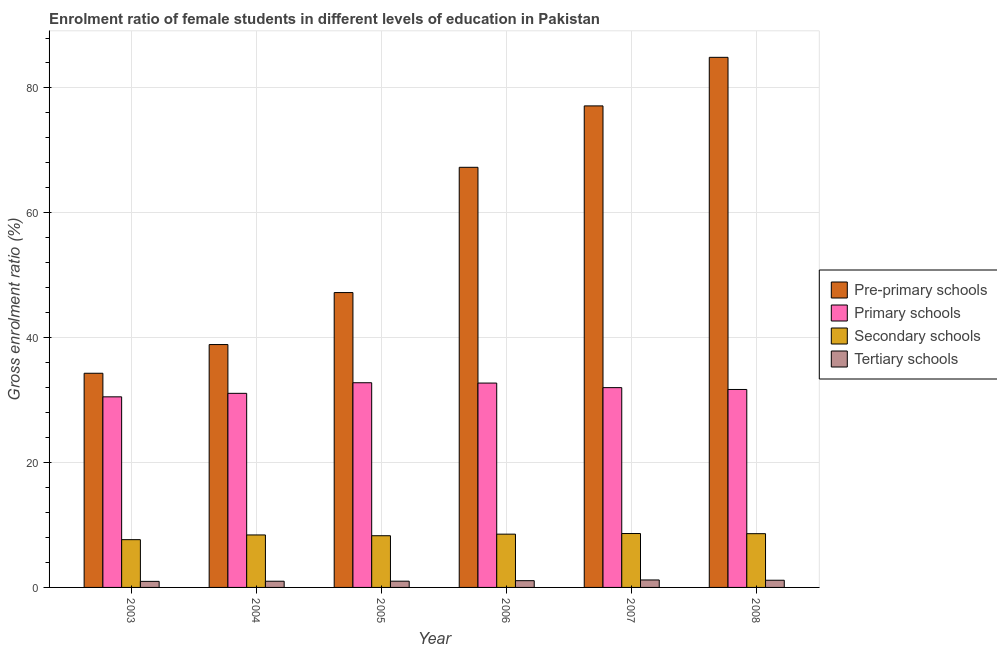How many different coloured bars are there?
Provide a succinct answer. 4. Are the number of bars per tick equal to the number of legend labels?
Give a very brief answer. Yes. How many bars are there on the 5th tick from the left?
Give a very brief answer. 4. How many bars are there on the 1st tick from the right?
Your response must be concise. 4. What is the label of the 4th group of bars from the left?
Provide a succinct answer. 2006. What is the gross enrolment ratio(male) in primary schools in 2005?
Provide a succinct answer. 32.79. Across all years, what is the maximum gross enrolment ratio(male) in tertiary schools?
Your answer should be compact. 1.2. Across all years, what is the minimum gross enrolment ratio(male) in tertiary schools?
Give a very brief answer. 0.97. In which year was the gross enrolment ratio(male) in primary schools maximum?
Your answer should be very brief. 2005. In which year was the gross enrolment ratio(male) in tertiary schools minimum?
Provide a succinct answer. 2003. What is the total gross enrolment ratio(male) in secondary schools in the graph?
Your answer should be very brief. 50.11. What is the difference between the gross enrolment ratio(male) in pre-primary schools in 2004 and that in 2008?
Offer a terse response. -46. What is the difference between the gross enrolment ratio(male) in pre-primary schools in 2004 and the gross enrolment ratio(male) in primary schools in 2006?
Your answer should be very brief. -28.39. What is the average gross enrolment ratio(male) in tertiary schools per year?
Your answer should be compact. 1.07. What is the ratio of the gross enrolment ratio(male) in pre-primary schools in 2004 to that in 2005?
Ensure brevity in your answer.  0.82. What is the difference between the highest and the second highest gross enrolment ratio(male) in primary schools?
Your answer should be compact. 0.05. What is the difference between the highest and the lowest gross enrolment ratio(male) in secondary schools?
Give a very brief answer. 0.98. Is the sum of the gross enrolment ratio(male) in pre-primary schools in 2005 and 2007 greater than the maximum gross enrolment ratio(male) in secondary schools across all years?
Your response must be concise. Yes. Is it the case that in every year, the sum of the gross enrolment ratio(male) in primary schools and gross enrolment ratio(male) in secondary schools is greater than the sum of gross enrolment ratio(male) in tertiary schools and gross enrolment ratio(male) in pre-primary schools?
Provide a short and direct response. Yes. What does the 4th bar from the left in 2005 represents?
Keep it short and to the point. Tertiary schools. What does the 4th bar from the right in 2008 represents?
Offer a very short reply. Pre-primary schools. Is it the case that in every year, the sum of the gross enrolment ratio(male) in pre-primary schools and gross enrolment ratio(male) in primary schools is greater than the gross enrolment ratio(male) in secondary schools?
Offer a very short reply. Yes. How many years are there in the graph?
Offer a terse response. 6. Does the graph contain grids?
Your answer should be very brief. Yes. Where does the legend appear in the graph?
Ensure brevity in your answer.  Center right. How are the legend labels stacked?
Your answer should be very brief. Vertical. What is the title of the graph?
Provide a succinct answer. Enrolment ratio of female students in different levels of education in Pakistan. What is the Gross enrolment ratio (%) of Pre-primary schools in 2003?
Your answer should be compact. 34.3. What is the Gross enrolment ratio (%) of Primary schools in 2003?
Your answer should be very brief. 30.53. What is the Gross enrolment ratio (%) of Secondary schools in 2003?
Make the answer very short. 7.65. What is the Gross enrolment ratio (%) in Tertiary schools in 2003?
Ensure brevity in your answer.  0.97. What is the Gross enrolment ratio (%) in Pre-primary schools in 2004?
Provide a short and direct response. 38.9. What is the Gross enrolment ratio (%) in Primary schools in 2004?
Give a very brief answer. 31.09. What is the Gross enrolment ratio (%) of Secondary schools in 2004?
Give a very brief answer. 8.41. What is the Gross enrolment ratio (%) of Tertiary schools in 2004?
Your answer should be compact. 0.99. What is the Gross enrolment ratio (%) of Pre-primary schools in 2005?
Give a very brief answer. 47.23. What is the Gross enrolment ratio (%) in Primary schools in 2005?
Offer a very short reply. 32.79. What is the Gross enrolment ratio (%) of Secondary schools in 2005?
Your answer should be very brief. 8.28. What is the Gross enrolment ratio (%) in Tertiary schools in 2005?
Your answer should be compact. 1. What is the Gross enrolment ratio (%) in Pre-primary schools in 2006?
Your response must be concise. 67.29. What is the Gross enrolment ratio (%) in Primary schools in 2006?
Offer a terse response. 32.73. What is the Gross enrolment ratio (%) in Secondary schools in 2006?
Your answer should be compact. 8.53. What is the Gross enrolment ratio (%) in Tertiary schools in 2006?
Offer a terse response. 1.08. What is the Gross enrolment ratio (%) of Pre-primary schools in 2007?
Offer a very short reply. 77.13. What is the Gross enrolment ratio (%) of Primary schools in 2007?
Your response must be concise. 32. What is the Gross enrolment ratio (%) in Secondary schools in 2007?
Provide a succinct answer. 8.63. What is the Gross enrolment ratio (%) in Tertiary schools in 2007?
Your answer should be very brief. 1.2. What is the Gross enrolment ratio (%) of Pre-primary schools in 2008?
Provide a succinct answer. 84.91. What is the Gross enrolment ratio (%) of Primary schools in 2008?
Provide a short and direct response. 31.7. What is the Gross enrolment ratio (%) of Secondary schools in 2008?
Your answer should be very brief. 8.61. What is the Gross enrolment ratio (%) of Tertiary schools in 2008?
Ensure brevity in your answer.  1.15. Across all years, what is the maximum Gross enrolment ratio (%) of Pre-primary schools?
Keep it short and to the point. 84.91. Across all years, what is the maximum Gross enrolment ratio (%) of Primary schools?
Keep it short and to the point. 32.79. Across all years, what is the maximum Gross enrolment ratio (%) in Secondary schools?
Ensure brevity in your answer.  8.63. Across all years, what is the maximum Gross enrolment ratio (%) in Tertiary schools?
Provide a succinct answer. 1.2. Across all years, what is the minimum Gross enrolment ratio (%) in Pre-primary schools?
Give a very brief answer. 34.3. Across all years, what is the minimum Gross enrolment ratio (%) of Primary schools?
Keep it short and to the point. 30.53. Across all years, what is the minimum Gross enrolment ratio (%) in Secondary schools?
Offer a very short reply. 7.65. Across all years, what is the minimum Gross enrolment ratio (%) in Tertiary schools?
Provide a succinct answer. 0.97. What is the total Gross enrolment ratio (%) of Pre-primary schools in the graph?
Offer a terse response. 349.76. What is the total Gross enrolment ratio (%) in Primary schools in the graph?
Provide a short and direct response. 190.84. What is the total Gross enrolment ratio (%) of Secondary schools in the graph?
Ensure brevity in your answer.  50.11. What is the total Gross enrolment ratio (%) in Tertiary schools in the graph?
Provide a succinct answer. 6.39. What is the difference between the Gross enrolment ratio (%) of Pre-primary schools in 2003 and that in 2004?
Make the answer very short. -4.6. What is the difference between the Gross enrolment ratio (%) in Primary schools in 2003 and that in 2004?
Your answer should be very brief. -0.56. What is the difference between the Gross enrolment ratio (%) in Secondary schools in 2003 and that in 2004?
Provide a succinct answer. -0.76. What is the difference between the Gross enrolment ratio (%) in Tertiary schools in 2003 and that in 2004?
Offer a very short reply. -0.02. What is the difference between the Gross enrolment ratio (%) in Pre-primary schools in 2003 and that in 2005?
Give a very brief answer. -12.92. What is the difference between the Gross enrolment ratio (%) of Primary schools in 2003 and that in 2005?
Ensure brevity in your answer.  -2.26. What is the difference between the Gross enrolment ratio (%) in Secondary schools in 2003 and that in 2005?
Give a very brief answer. -0.63. What is the difference between the Gross enrolment ratio (%) in Tertiary schools in 2003 and that in 2005?
Your answer should be very brief. -0.03. What is the difference between the Gross enrolment ratio (%) in Pre-primary schools in 2003 and that in 2006?
Provide a succinct answer. -32.99. What is the difference between the Gross enrolment ratio (%) in Primary schools in 2003 and that in 2006?
Give a very brief answer. -2.2. What is the difference between the Gross enrolment ratio (%) in Secondary schools in 2003 and that in 2006?
Provide a succinct answer. -0.88. What is the difference between the Gross enrolment ratio (%) in Tertiary schools in 2003 and that in 2006?
Keep it short and to the point. -0.11. What is the difference between the Gross enrolment ratio (%) in Pre-primary schools in 2003 and that in 2007?
Offer a very short reply. -42.82. What is the difference between the Gross enrolment ratio (%) of Primary schools in 2003 and that in 2007?
Provide a succinct answer. -1.48. What is the difference between the Gross enrolment ratio (%) of Secondary schools in 2003 and that in 2007?
Your answer should be very brief. -0.98. What is the difference between the Gross enrolment ratio (%) in Tertiary schools in 2003 and that in 2007?
Your answer should be very brief. -0.23. What is the difference between the Gross enrolment ratio (%) in Pre-primary schools in 2003 and that in 2008?
Offer a terse response. -50.6. What is the difference between the Gross enrolment ratio (%) in Primary schools in 2003 and that in 2008?
Keep it short and to the point. -1.18. What is the difference between the Gross enrolment ratio (%) of Secondary schools in 2003 and that in 2008?
Offer a terse response. -0.96. What is the difference between the Gross enrolment ratio (%) in Tertiary schools in 2003 and that in 2008?
Give a very brief answer. -0.18. What is the difference between the Gross enrolment ratio (%) of Pre-primary schools in 2004 and that in 2005?
Your answer should be compact. -8.32. What is the difference between the Gross enrolment ratio (%) of Primary schools in 2004 and that in 2005?
Make the answer very short. -1.7. What is the difference between the Gross enrolment ratio (%) of Secondary schools in 2004 and that in 2005?
Ensure brevity in your answer.  0.13. What is the difference between the Gross enrolment ratio (%) of Tertiary schools in 2004 and that in 2005?
Offer a very short reply. -0.01. What is the difference between the Gross enrolment ratio (%) of Pre-primary schools in 2004 and that in 2006?
Ensure brevity in your answer.  -28.39. What is the difference between the Gross enrolment ratio (%) of Primary schools in 2004 and that in 2006?
Give a very brief answer. -1.64. What is the difference between the Gross enrolment ratio (%) in Secondary schools in 2004 and that in 2006?
Keep it short and to the point. -0.13. What is the difference between the Gross enrolment ratio (%) in Tertiary schools in 2004 and that in 2006?
Ensure brevity in your answer.  -0.09. What is the difference between the Gross enrolment ratio (%) of Pre-primary schools in 2004 and that in 2007?
Offer a very short reply. -38.22. What is the difference between the Gross enrolment ratio (%) in Primary schools in 2004 and that in 2007?
Make the answer very short. -0.92. What is the difference between the Gross enrolment ratio (%) of Secondary schools in 2004 and that in 2007?
Your answer should be compact. -0.23. What is the difference between the Gross enrolment ratio (%) of Tertiary schools in 2004 and that in 2007?
Give a very brief answer. -0.2. What is the difference between the Gross enrolment ratio (%) of Pre-primary schools in 2004 and that in 2008?
Your answer should be compact. -46. What is the difference between the Gross enrolment ratio (%) of Primary schools in 2004 and that in 2008?
Your answer should be very brief. -0.62. What is the difference between the Gross enrolment ratio (%) of Secondary schools in 2004 and that in 2008?
Make the answer very short. -0.2. What is the difference between the Gross enrolment ratio (%) in Tertiary schools in 2004 and that in 2008?
Offer a terse response. -0.16. What is the difference between the Gross enrolment ratio (%) in Pre-primary schools in 2005 and that in 2006?
Make the answer very short. -20.07. What is the difference between the Gross enrolment ratio (%) in Primary schools in 2005 and that in 2006?
Keep it short and to the point. 0.05. What is the difference between the Gross enrolment ratio (%) in Secondary schools in 2005 and that in 2006?
Offer a terse response. -0.25. What is the difference between the Gross enrolment ratio (%) of Tertiary schools in 2005 and that in 2006?
Your response must be concise. -0.08. What is the difference between the Gross enrolment ratio (%) of Pre-primary schools in 2005 and that in 2007?
Make the answer very short. -29.9. What is the difference between the Gross enrolment ratio (%) of Primary schools in 2005 and that in 2007?
Offer a very short reply. 0.78. What is the difference between the Gross enrolment ratio (%) in Secondary schools in 2005 and that in 2007?
Provide a short and direct response. -0.35. What is the difference between the Gross enrolment ratio (%) in Tertiary schools in 2005 and that in 2007?
Keep it short and to the point. -0.19. What is the difference between the Gross enrolment ratio (%) in Pre-primary schools in 2005 and that in 2008?
Your answer should be very brief. -37.68. What is the difference between the Gross enrolment ratio (%) of Primary schools in 2005 and that in 2008?
Keep it short and to the point. 1.08. What is the difference between the Gross enrolment ratio (%) in Secondary schools in 2005 and that in 2008?
Your answer should be compact. -0.33. What is the difference between the Gross enrolment ratio (%) of Tertiary schools in 2005 and that in 2008?
Your answer should be compact. -0.15. What is the difference between the Gross enrolment ratio (%) of Pre-primary schools in 2006 and that in 2007?
Your answer should be very brief. -9.83. What is the difference between the Gross enrolment ratio (%) in Primary schools in 2006 and that in 2007?
Keep it short and to the point. 0.73. What is the difference between the Gross enrolment ratio (%) of Secondary schools in 2006 and that in 2007?
Keep it short and to the point. -0.1. What is the difference between the Gross enrolment ratio (%) of Tertiary schools in 2006 and that in 2007?
Offer a very short reply. -0.12. What is the difference between the Gross enrolment ratio (%) in Pre-primary schools in 2006 and that in 2008?
Your response must be concise. -17.61. What is the difference between the Gross enrolment ratio (%) in Primary schools in 2006 and that in 2008?
Offer a very short reply. 1.03. What is the difference between the Gross enrolment ratio (%) in Secondary schools in 2006 and that in 2008?
Offer a very short reply. -0.08. What is the difference between the Gross enrolment ratio (%) in Tertiary schools in 2006 and that in 2008?
Offer a terse response. -0.07. What is the difference between the Gross enrolment ratio (%) of Pre-primary schools in 2007 and that in 2008?
Give a very brief answer. -7.78. What is the difference between the Gross enrolment ratio (%) in Primary schools in 2007 and that in 2008?
Keep it short and to the point. 0.3. What is the difference between the Gross enrolment ratio (%) in Secondary schools in 2007 and that in 2008?
Your response must be concise. 0.03. What is the difference between the Gross enrolment ratio (%) in Tertiary schools in 2007 and that in 2008?
Your answer should be compact. 0.04. What is the difference between the Gross enrolment ratio (%) in Pre-primary schools in 2003 and the Gross enrolment ratio (%) in Primary schools in 2004?
Ensure brevity in your answer.  3.22. What is the difference between the Gross enrolment ratio (%) of Pre-primary schools in 2003 and the Gross enrolment ratio (%) of Secondary schools in 2004?
Provide a succinct answer. 25.9. What is the difference between the Gross enrolment ratio (%) in Pre-primary schools in 2003 and the Gross enrolment ratio (%) in Tertiary schools in 2004?
Ensure brevity in your answer.  33.31. What is the difference between the Gross enrolment ratio (%) of Primary schools in 2003 and the Gross enrolment ratio (%) of Secondary schools in 2004?
Your answer should be very brief. 22.12. What is the difference between the Gross enrolment ratio (%) of Primary schools in 2003 and the Gross enrolment ratio (%) of Tertiary schools in 2004?
Ensure brevity in your answer.  29.53. What is the difference between the Gross enrolment ratio (%) in Secondary schools in 2003 and the Gross enrolment ratio (%) in Tertiary schools in 2004?
Provide a succinct answer. 6.66. What is the difference between the Gross enrolment ratio (%) in Pre-primary schools in 2003 and the Gross enrolment ratio (%) in Primary schools in 2005?
Provide a short and direct response. 1.52. What is the difference between the Gross enrolment ratio (%) of Pre-primary schools in 2003 and the Gross enrolment ratio (%) of Secondary schools in 2005?
Make the answer very short. 26.02. What is the difference between the Gross enrolment ratio (%) of Pre-primary schools in 2003 and the Gross enrolment ratio (%) of Tertiary schools in 2005?
Provide a succinct answer. 33.3. What is the difference between the Gross enrolment ratio (%) of Primary schools in 2003 and the Gross enrolment ratio (%) of Secondary schools in 2005?
Your answer should be very brief. 22.25. What is the difference between the Gross enrolment ratio (%) of Primary schools in 2003 and the Gross enrolment ratio (%) of Tertiary schools in 2005?
Your answer should be compact. 29.53. What is the difference between the Gross enrolment ratio (%) of Secondary schools in 2003 and the Gross enrolment ratio (%) of Tertiary schools in 2005?
Ensure brevity in your answer.  6.65. What is the difference between the Gross enrolment ratio (%) of Pre-primary schools in 2003 and the Gross enrolment ratio (%) of Primary schools in 2006?
Your answer should be compact. 1.57. What is the difference between the Gross enrolment ratio (%) of Pre-primary schools in 2003 and the Gross enrolment ratio (%) of Secondary schools in 2006?
Ensure brevity in your answer.  25.77. What is the difference between the Gross enrolment ratio (%) of Pre-primary schools in 2003 and the Gross enrolment ratio (%) of Tertiary schools in 2006?
Ensure brevity in your answer.  33.22. What is the difference between the Gross enrolment ratio (%) of Primary schools in 2003 and the Gross enrolment ratio (%) of Secondary schools in 2006?
Offer a terse response. 21.99. What is the difference between the Gross enrolment ratio (%) of Primary schools in 2003 and the Gross enrolment ratio (%) of Tertiary schools in 2006?
Offer a very short reply. 29.45. What is the difference between the Gross enrolment ratio (%) in Secondary schools in 2003 and the Gross enrolment ratio (%) in Tertiary schools in 2006?
Keep it short and to the point. 6.57. What is the difference between the Gross enrolment ratio (%) of Pre-primary schools in 2003 and the Gross enrolment ratio (%) of Primary schools in 2007?
Provide a short and direct response. 2.3. What is the difference between the Gross enrolment ratio (%) of Pre-primary schools in 2003 and the Gross enrolment ratio (%) of Secondary schools in 2007?
Keep it short and to the point. 25.67. What is the difference between the Gross enrolment ratio (%) of Pre-primary schools in 2003 and the Gross enrolment ratio (%) of Tertiary schools in 2007?
Keep it short and to the point. 33.11. What is the difference between the Gross enrolment ratio (%) of Primary schools in 2003 and the Gross enrolment ratio (%) of Secondary schools in 2007?
Give a very brief answer. 21.89. What is the difference between the Gross enrolment ratio (%) in Primary schools in 2003 and the Gross enrolment ratio (%) in Tertiary schools in 2007?
Offer a terse response. 29.33. What is the difference between the Gross enrolment ratio (%) of Secondary schools in 2003 and the Gross enrolment ratio (%) of Tertiary schools in 2007?
Ensure brevity in your answer.  6.45. What is the difference between the Gross enrolment ratio (%) of Pre-primary schools in 2003 and the Gross enrolment ratio (%) of Primary schools in 2008?
Give a very brief answer. 2.6. What is the difference between the Gross enrolment ratio (%) in Pre-primary schools in 2003 and the Gross enrolment ratio (%) in Secondary schools in 2008?
Your response must be concise. 25.69. What is the difference between the Gross enrolment ratio (%) in Pre-primary schools in 2003 and the Gross enrolment ratio (%) in Tertiary schools in 2008?
Your answer should be very brief. 33.15. What is the difference between the Gross enrolment ratio (%) in Primary schools in 2003 and the Gross enrolment ratio (%) in Secondary schools in 2008?
Your response must be concise. 21.92. What is the difference between the Gross enrolment ratio (%) in Primary schools in 2003 and the Gross enrolment ratio (%) in Tertiary schools in 2008?
Your answer should be compact. 29.37. What is the difference between the Gross enrolment ratio (%) of Secondary schools in 2003 and the Gross enrolment ratio (%) of Tertiary schools in 2008?
Your answer should be compact. 6.5. What is the difference between the Gross enrolment ratio (%) of Pre-primary schools in 2004 and the Gross enrolment ratio (%) of Primary schools in 2005?
Ensure brevity in your answer.  6.12. What is the difference between the Gross enrolment ratio (%) in Pre-primary schools in 2004 and the Gross enrolment ratio (%) in Secondary schools in 2005?
Your answer should be very brief. 30.62. What is the difference between the Gross enrolment ratio (%) of Pre-primary schools in 2004 and the Gross enrolment ratio (%) of Tertiary schools in 2005?
Keep it short and to the point. 37.9. What is the difference between the Gross enrolment ratio (%) in Primary schools in 2004 and the Gross enrolment ratio (%) in Secondary schools in 2005?
Your answer should be compact. 22.81. What is the difference between the Gross enrolment ratio (%) of Primary schools in 2004 and the Gross enrolment ratio (%) of Tertiary schools in 2005?
Provide a short and direct response. 30.09. What is the difference between the Gross enrolment ratio (%) of Secondary schools in 2004 and the Gross enrolment ratio (%) of Tertiary schools in 2005?
Your response must be concise. 7.41. What is the difference between the Gross enrolment ratio (%) of Pre-primary schools in 2004 and the Gross enrolment ratio (%) of Primary schools in 2006?
Offer a terse response. 6.17. What is the difference between the Gross enrolment ratio (%) in Pre-primary schools in 2004 and the Gross enrolment ratio (%) in Secondary schools in 2006?
Keep it short and to the point. 30.37. What is the difference between the Gross enrolment ratio (%) in Pre-primary schools in 2004 and the Gross enrolment ratio (%) in Tertiary schools in 2006?
Your answer should be compact. 37.82. What is the difference between the Gross enrolment ratio (%) in Primary schools in 2004 and the Gross enrolment ratio (%) in Secondary schools in 2006?
Your answer should be compact. 22.55. What is the difference between the Gross enrolment ratio (%) in Primary schools in 2004 and the Gross enrolment ratio (%) in Tertiary schools in 2006?
Ensure brevity in your answer.  30.01. What is the difference between the Gross enrolment ratio (%) of Secondary schools in 2004 and the Gross enrolment ratio (%) of Tertiary schools in 2006?
Provide a short and direct response. 7.33. What is the difference between the Gross enrolment ratio (%) in Pre-primary schools in 2004 and the Gross enrolment ratio (%) in Primary schools in 2007?
Provide a succinct answer. 6.9. What is the difference between the Gross enrolment ratio (%) in Pre-primary schools in 2004 and the Gross enrolment ratio (%) in Secondary schools in 2007?
Your response must be concise. 30.27. What is the difference between the Gross enrolment ratio (%) of Pre-primary schools in 2004 and the Gross enrolment ratio (%) of Tertiary schools in 2007?
Your response must be concise. 37.71. What is the difference between the Gross enrolment ratio (%) of Primary schools in 2004 and the Gross enrolment ratio (%) of Secondary schools in 2007?
Keep it short and to the point. 22.45. What is the difference between the Gross enrolment ratio (%) in Primary schools in 2004 and the Gross enrolment ratio (%) in Tertiary schools in 2007?
Your response must be concise. 29.89. What is the difference between the Gross enrolment ratio (%) of Secondary schools in 2004 and the Gross enrolment ratio (%) of Tertiary schools in 2007?
Your answer should be compact. 7.21. What is the difference between the Gross enrolment ratio (%) in Pre-primary schools in 2004 and the Gross enrolment ratio (%) in Primary schools in 2008?
Offer a terse response. 7.2. What is the difference between the Gross enrolment ratio (%) in Pre-primary schools in 2004 and the Gross enrolment ratio (%) in Secondary schools in 2008?
Provide a succinct answer. 30.29. What is the difference between the Gross enrolment ratio (%) of Pre-primary schools in 2004 and the Gross enrolment ratio (%) of Tertiary schools in 2008?
Provide a short and direct response. 37.75. What is the difference between the Gross enrolment ratio (%) in Primary schools in 2004 and the Gross enrolment ratio (%) in Secondary schools in 2008?
Keep it short and to the point. 22.48. What is the difference between the Gross enrolment ratio (%) of Primary schools in 2004 and the Gross enrolment ratio (%) of Tertiary schools in 2008?
Provide a succinct answer. 29.94. What is the difference between the Gross enrolment ratio (%) in Secondary schools in 2004 and the Gross enrolment ratio (%) in Tertiary schools in 2008?
Ensure brevity in your answer.  7.25. What is the difference between the Gross enrolment ratio (%) in Pre-primary schools in 2005 and the Gross enrolment ratio (%) in Primary schools in 2006?
Your answer should be very brief. 14.5. What is the difference between the Gross enrolment ratio (%) of Pre-primary schools in 2005 and the Gross enrolment ratio (%) of Secondary schools in 2006?
Your answer should be compact. 38.69. What is the difference between the Gross enrolment ratio (%) in Pre-primary schools in 2005 and the Gross enrolment ratio (%) in Tertiary schools in 2006?
Your answer should be very brief. 46.15. What is the difference between the Gross enrolment ratio (%) of Primary schools in 2005 and the Gross enrolment ratio (%) of Secondary schools in 2006?
Make the answer very short. 24.25. What is the difference between the Gross enrolment ratio (%) in Primary schools in 2005 and the Gross enrolment ratio (%) in Tertiary schools in 2006?
Your answer should be very brief. 31.71. What is the difference between the Gross enrolment ratio (%) in Secondary schools in 2005 and the Gross enrolment ratio (%) in Tertiary schools in 2006?
Give a very brief answer. 7.2. What is the difference between the Gross enrolment ratio (%) of Pre-primary schools in 2005 and the Gross enrolment ratio (%) of Primary schools in 2007?
Provide a succinct answer. 15.22. What is the difference between the Gross enrolment ratio (%) in Pre-primary schools in 2005 and the Gross enrolment ratio (%) in Secondary schools in 2007?
Make the answer very short. 38.59. What is the difference between the Gross enrolment ratio (%) in Pre-primary schools in 2005 and the Gross enrolment ratio (%) in Tertiary schools in 2007?
Provide a short and direct response. 46.03. What is the difference between the Gross enrolment ratio (%) in Primary schools in 2005 and the Gross enrolment ratio (%) in Secondary schools in 2007?
Offer a terse response. 24.15. What is the difference between the Gross enrolment ratio (%) of Primary schools in 2005 and the Gross enrolment ratio (%) of Tertiary schools in 2007?
Make the answer very short. 31.59. What is the difference between the Gross enrolment ratio (%) in Secondary schools in 2005 and the Gross enrolment ratio (%) in Tertiary schools in 2007?
Make the answer very short. 7.09. What is the difference between the Gross enrolment ratio (%) of Pre-primary schools in 2005 and the Gross enrolment ratio (%) of Primary schools in 2008?
Provide a short and direct response. 15.52. What is the difference between the Gross enrolment ratio (%) in Pre-primary schools in 2005 and the Gross enrolment ratio (%) in Secondary schools in 2008?
Your answer should be compact. 38.62. What is the difference between the Gross enrolment ratio (%) in Pre-primary schools in 2005 and the Gross enrolment ratio (%) in Tertiary schools in 2008?
Provide a short and direct response. 46.07. What is the difference between the Gross enrolment ratio (%) in Primary schools in 2005 and the Gross enrolment ratio (%) in Secondary schools in 2008?
Offer a very short reply. 24.18. What is the difference between the Gross enrolment ratio (%) of Primary schools in 2005 and the Gross enrolment ratio (%) of Tertiary schools in 2008?
Your answer should be compact. 31.63. What is the difference between the Gross enrolment ratio (%) in Secondary schools in 2005 and the Gross enrolment ratio (%) in Tertiary schools in 2008?
Your answer should be compact. 7.13. What is the difference between the Gross enrolment ratio (%) in Pre-primary schools in 2006 and the Gross enrolment ratio (%) in Primary schools in 2007?
Your answer should be very brief. 35.29. What is the difference between the Gross enrolment ratio (%) in Pre-primary schools in 2006 and the Gross enrolment ratio (%) in Secondary schools in 2007?
Make the answer very short. 58.66. What is the difference between the Gross enrolment ratio (%) in Pre-primary schools in 2006 and the Gross enrolment ratio (%) in Tertiary schools in 2007?
Your response must be concise. 66.1. What is the difference between the Gross enrolment ratio (%) of Primary schools in 2006 and the Gross enrolment ratio (%) of Secondary schools in 2007?
Give a very brief answer. 24.1. What is the difference between the Gross enrolment ratio (%) of Primary schools in 2006 and the Gross enrolment ratio (%) of Tertiary schools in 2007?
Offer a very short reply. 31.54. What is the difference between the Gross enrolment ratio (%) in Secondary schools in 2006 and the Gross enrolment ratio (%) in Tertiary schools in 2007?
Offer a terse response. 7.34. What is the difference between the Gross enrolment ratio (%) in Pre-primary schools in 2006 and the Gross enrolment ratio (%) in Primary schools in 2008?
Provide a succinct answer. 35.59. What is the difference between the Gross enrolment ratio (%) of Pre-primary schools in 2006 and the Gross enrolment ratio (%) of Secondary schools in 2008?
Ensure brevity in your answer.  58.68. What is the difference between the Gross enrolment ratio (%) in Pre-primary schools in 2006 and the Gross enrolment ratio (%) in Tertiary schools in 2008?
Give a very brief answer. 66.14. What is the difference between the Gross enrolment ratio (%) of Primary schools in 2006 and the Gross enrolment ratio (%) of Secondary schools in 2008?
Offer a terse response. 24.12. What is the difference between the Gross enrolment ratio (%) in Primary schools in 2006 and the Gross enrolment ratio (%) in Tertiary schools in 2008?
Ensure brevity in your answer.  31.58. What is the difference between the Gross enrolment ratio (%) of Secondary schools in 2006 and the Gross enrolment ratio (%) of Tertiary schools in 2008?
Provide a succinct answer. 7.38. What is the difference between the Gross enrolment ratio (%) of Pre-primary schools in 2007 and the Gross enrolment ratio (%) of Primary schools in 2008?
Provide a short and direct response. 45.42. What is the difference between the Gross enrolment ratio (%) of Pre-primary schools in 2007 and the Gross enrolment ratio (%) of Secondary schools in 2008?
Ensure brevity in your answer.  68.52. What is the difference between the Gross enrolment ratio (%) of Pre-primary schools in 2007 and the Gross enrolment ratio (%) of Tertiary schools in 2008?
Offer a terse response. 75.97. What is the difference between the Gross enrolment ratio (%) in Primary schools in 2007 and the Gross enrolment ratio (%) in Secondary schools in 2008?
Keep it short and to the point. 23.39. What is the difference between the Gross enrolment ratio (%) in Primary schools in 2007 and the Gross enrolment ratio (%) in Tertiary schools in 2008?
Offer a very short reply. 30.85. What is the difference between the Gross enrolment ratio (%) in Secondary schools in 2007 and the Gross enrolment ratio (%) in Tertiary schools in 2008?
Your response must be concise. 7.48. What is the average Gross enrolment ratio (%) of Pre-primary schools per year?
Offer a very short reply. 58.29. What is the average Gross enrolment ratio (%) in Primary schools per year?
Make the answer very short. 31.81. What is the average Gross enrolment ratio (%) of Secondary schools per year?
Make the answer very short. 8.35. What is the average Gross enrolment ratio (%) of Tertiary schools per year?
Your response must be concise. 1.07. In the year 2003, what is the difference between the Gross enrolment ratio (%) of Pre-primary schools and Gross enrolment ratio (%) of Primary schools?
Offer a very short reply. 3.78. In the year 2003, what is the difference between the Gross enrolment ratio (%) in Pre-primary schools and Gross enrolment ratio (%) in Secondary schools?
Your response must be concise. 26.65. In the year 2003, what is the difference between the Gross enrolment ratio (%) in Pre-primary schools and Gross enrolment ratio (%) in Tertiary schools?
Give a very brief answer. 33.33. In the year 2003, what is the difference between the Gross enrolment ratio (%) of Primary schools and Gross enrolment ratio (%) of Secondary schools?
Give a very brief answer. 22.88. In the year 2003, what is the difference between the Gross enrolment ratio (%) of Primary schools and Gross enrolment ratio (%) of Tertiary schools?
Your answer should be compact. 29.56. In the year 2003, what is the difference between the Gross enrolment ratio (%) of Secondary schools and Gross enrolment ratio (%) of Tertiary schools?
Offer a terse response. 6.68. In the year 2004, what is the difference between the Gross enrolment ratio (%) of Pre-primary schools and Gross enrolment ratio (%) of Primary schools?
Provide a short and direct response. 7.81. In the year 2004, what is the difference between the Gross enrolment ratio (%) in Pre-primary schools and Gross enrolment ratio (%) in Secondary schools?
Provide a short and direct response. 30.5. In the year 2004, what is the difference between the Gross enrolment ratio (%) of Pre-primary schools and Gross enrolment ratio (%) of Tertiary schools?
Provide a short and direct response. 37.91. In the year 2004, what is the difference between the Gross enrolment ratio (%) of Primary schools and Gross enrolment ratio (%) of Secondary schools?
Your answer should be compact. 22.68. In the year 2004, what is the difference between the Gross enrolment ratio (%) in Primary schools and Gross enrolment ratio (%) in Tertiary schools?
Your answer should be very brief. 30.09. In the year 2004, what is the difference between the Gross enrolment ratio (%) of Secondary schools and Gross enrolment ratio (%) of Tertiary schools?
Your answer should be compact. 7.41. In the year 2005, what is the difference between the Gross enrolment ratio (%) of Pre-primary schools and Gross enrolment ratio (%) of Primary schools?
Your answer should be very brief. 14.44. In the year 2005, what is the difference between the Gross enrolment ratio (%) in Pre-primary schools and Gross enrolment ratio (%) in Secondary schools?
Your response must be concise. 38.95. In the year 2005, what is the difference between the Gross enrolment ratio (%) in Pre-primary schools and Gross enrolment ratio (%) in Tertiary schools?
Your answer should be compact. 46.23. In the year 2005, what is the difference between the Gross enrolment ratio (%) in Primary schools and Gross enrolment ratio (%) in Secondary schools?
Give a very brief answer. 24.5. In the year 2005, what is the difference between the Gross enrolment ratio (%) in Primary schools and Gross enrolment ratio (%) in Tertiary schools?
Give a very brief answer. 31.78. In the year 2005, what is the difference between the Gross enrolment ratio (%) of Secondary schools and Gross enrolment ratio (%) of Tertiary schools?
Your answer should be very brief. 7.28. In the year 2006, what is the difference between the Gross enrolment ratio (%) of Pre-primary schools and Gross enrolment ratio (%) of Primary schools?
Provide a succinct answer. 34.56. In the year 2006, what is the difference between the Gross enrolment ratio (%) in Pre-primary schools and Gross enrolment ratio (%) in Secondary schools?
Your answer should be compact. 58.76. In the year 2006, what is the difference between the Gross enrolment ratio (%) of Pre-primary schools and Gross enrolment ratio (%) of Tertiary schools?
Give a very brief answer. 66.21. In the year 2006, what is the difference between the Gross enrolment ratio (%) of Primary schools and Gross enrolment ratio (%) of Secondary schools?
Ensure brevity in your answer.  24.2. In the year 2006, what is the difference between the Gross enrolment ratio (%) of Primary schools and Gross enrolment ratio (%) of Tertiary schools?
Provide a succinct answer. 31.65. In the year 2006, what is the difference between the Gross enrolment ratio (%) in Secondary schools and Gross enrolment ratio (%) in Tertiary schools?
Your response must be concise. 7.45. In the year 2007, what is the difference between the Gross enrolment ratio (%) in Pre-primary schools and Gross enrolment ratio (%) in Primary schools?
Make the answer very short. 45.12. In the year 2007, what is the difference between the Gross enrolment ratio (%) of Pre-primary schools and Gross enrolment ratio (%) of Secondary schools?
Make the answer very short. 68.49. In the year 2007, what is the difference between the Gross enrolment ratio (%) of Pre-primary schools and Gross enrolment ratio (%) of Tertiary schools?
Offer a very short reply. 75.93. In the year 2007, what is the difference between the Gross enrolment ratio (%) in Primary schools and Gross enrolment ratio (%) in Secondary schools?
Offer a terse response. 23.37. In the year 2007, what is the difference between the Gross enrolment ratio (%) in Primary schools and Gross enrolment ratio (%) in Tertiary schools?
Offer a very short reply. 30.81. In the year 2007, what is the difference between the Gross enrolment ratio (%) of Secondary schools and Gross enrolment ratio (%) of Tertiary schools?
Provide a succinct answer. 7.44. In the year 2008, what is the difference between the Gross enrolment ratio (%) of Pre-primary schools and Gross enrolment ratio (%) of Primary schools?
Keep it short and to the point. 53.2. In the year 2008, what is the difference between the Gross enrolment ratio (%) in Pre-primary schools and Gross enrolment ratio (%) in Secondary schools?
Your answer should be compact. 76.3. In the year 2008, what is the difference between the Gross enrolment ratio (%) in Pre-primary schools and Gross enrolment ratio (%) in Tertiary schools?
Your answer should be very brief. 83.75. In the year 2008, what is the difference between the Gross enrolment ratio (%) of Primary schools and Gross enrolment ratio (%) of Secondary schools?
Offer a terse response. 23.1. In the year 2008, what is the difference between the Gross enrolment ratio (%) in Primary schools and Gross enrolment ratio (%) in Tertiary schools?
Give a very brief answer. 30.55. In the year 2008, what is the difference between the Gross enrolment ratio (%) of Secondary schools and Gross enrolment ratio (%) of Tertiary schools?
Keep it short and to the point. 7.46. What is the ratio of the Gross enrolment ratio (%) in Pre-primary schools in 2003 to that in 2004?
Offer a very short reply. 0.88. What is the ratio of the Gross enrolment ratio (%) of Primary schools in 2003 to that in 2004?
Your response must be concise. 0.98. What is the ratio of the Gross enrolment ratio (%) of Secondary schools in 2003 to that in 2004?
Keep it short and to the point. 0.91. What is the ratio of the Gross enrolment ratio (%) in Tertiary schools in 2003 to that in 2004?
Provide a short and direct response. 0.98. What is the ratio of the Gross enrolment ratio (%) of Pre-primary schools in 2003 to that in 2005?
Offer a very short reply. 0.73. What is the ratio of the Gross enrolment ratio (%) in Primary schools in 2003 to that in 2005?
Ensure brevity in your answer.  0.93. What is the ratio of the Gross enrolment ratio (%) in Secondary schools in 2003 to that in 2005?
Offer a terse response. 0.92. What is the ratio of the Gross enrolment ratio (%) of Tertiary schools in 2003 to that in 2005?
Provide a short and direct response. 0.97. What is the ratio of the Gross enrolment ratio (%) of Pre-primary schools in 2003 to that in 2006?
Provide a succinct answer. 0.51. What is the ratio of the Gross enrolment ratio (%) in Primary schools in 2003 to that in 2006?
Make the answer very short. 0.93. What is the ratio of the Gross enrolment ratio (%) of Secondary schools in 2003 to that in 2006?
Ensure brevity in your answer.  0.9. What is the ratio of the Gross enrolment ratio (%) of Tertiary schools in 2003 to that in 2006?
Keep it short and to the point. 0.9. What is the ratio of the Gross enrolment ratio (%) of Pre-primary schools in 2003 to that in 2007?
Your response must be concise. 0.44. What is the ratio of the Gross enrolment ratio (%) in Primary schools in 2003 to that in 2007?
Give a very brief answer. 0.95. What is the ratio of the Gross enrolment ratio (%) in Secondary schools in 2003 to that in 2007?
Your response must be concise. 0.89. What is the ratio of the Gross enrolment ratio (%) of Tertiary schools in 2003 to that in 2007?
Make the answer very short. 0.81. What is the ratio of the Gross enrolment ratio (%) in Pre-primary schools in 2003 to that in 2008?
Your response must be concise. 0.4. What is the ratio of the Gross enrolment ratio (%) in Primary schools in 2003 to that in 2008?
Offer a very short reply. 0.96. What is the ratio of the Gross enrolment ratio (%) in Secondary schools in 2003 to that in 2008?
Your answer should be compact. 0.89. What is the ratio of the Gross enrolment ratio (%) of Tertiary schools in 2003 to that in 2008?
Give a very brief answer. 0.84. What is the ratio of the Gross enrolment ratio (%) in Pre-primary schools in 2004 to that in 2005?
Your answer should be compact. 0.82. What is the ratio of the Gross enrolment ratio (%) in Primary schools in 2004 to that in 2005?
Ensure brevity in your answer.  0.95. What is the ratio of the Gross enrolment ratio (%) in Secondary schools in 2004 to that in 2005?
Offer a terse response. 1.02. What is the ratio of the Gross enrolment ratio (%) in Tertiary schools in 2004 to that in 2005?
Offer a very short reply. 0.99. What is the ratio of the Gross enrolment ratio (%) in Pre-primary schools in 2004 to that in 2006?
Make the answer very short. 0.58. What is the ratio of the Gross enrolment ratio (%) in Primary schools in 2004 to that in 2006?
Offer a terse response. 0.95. What is the ratio of the Gross enrolment ratio (%) of Secondary schools in 2004 to that in 2006?
Give a very brief answer. 0.99. What is the ratio of the Gross enrolment ratio (%) of Tertiary schools in 2004 to that in 2006?
Ensure brevity in your answer.  0.92. What is the ratio of the Gross enrolment ratio (%) in Pre-primary schools in 2004 to that in 2007?
Your response must be concise. 0.5. What is the ratio of the Gross enrolment ratio (%) in Primary schools in 2004 to that in 2007?
Your response must be concise. 0.97. What is the ratio of the Gross enrolment ratio (%) in Secondary schools in 2004 to that in 2007?
Ensure brevity in your answer.  0.97. What is the ratio of the Gross enrolment ratio (%) of Tertiary schools in 2004 to that in 2007?
Provide a short and direct response. 0.83. What is the ratio of the Gross enrolment ratio (%) of Pre-primary schools in 2004 to that in 2008?
Offer a very short reply. 0.46. What is the ratio of the Gross enrolment ratio (%) of Primary schools in 2004 to that in 2008?
Provide a succinct answer. 0.98. What is the ratio of the Gross enrolment ratio (%) of Secondary schools in 2004 to that in 2008?
Your answer should be very brief. 0.98. What is the ratio of the Gross enrolment ratio (%) in Tertiary schools in 2004 to that in 2008?
Provide a succinct answer. 0.86. What is the ratio of the Gross enrolment ratio (%) in Pre-primary schools in 2005 to that in 2006?
Your response must be concise. 0.7. What is the ratio of the Gross enrolment ratio (%) of Secondary schools in 2005 to that in 2006?
Offer a very short reply. 0.97. What is the ratio of the Gross enrolment ratio (%) of Tertiary schools in 2005 to that in 2006?
Offer a terse response. 0.93. What is the ratio of the Gross enrolment ratio (%) in Pre-primary schools in 2005 to that in 2007?
Give a very brief answer. 0.61. What is the ratio of the Gross enrolment ratio (%) of Primary schools in 2005 to that in 2007?
Provide a short and direct response. 1.02. What is the ratio of the Gross enrolment ratio (%) in Secondary schools in 2005 to that in 2007?
Provide a succinct answer. 0.96. What is the ratio of the Gross enrolment ratio (%) of Tertiary schools in 2005 to that in 2007?
Provide a succinct answer. 0.84. What is the ratio of the Gross enrolment ratio (%) of Pre-primary schools in 2005 to that in 2008?
Your answer should be very brief. 0.56. What is the ratio of the Gross enrolment ratio (%) of Primary schools in 2005 to that in 2008?
Your response must be concise. 1.03. What is the ratio of the Gross enrolment ratio (%) in Secondary schools in 2005 to that in 2008?
Your answer should be very brief. 0.96. What is the ratio of the Gross enrolment ratio (%) of Tertiary schools in 2005 to that in 2008?
Keep it short and to the point. 0.87. What is the ratio of the Gross enrolment ratio (%) in Pre-primary schools in 2006 to that in 2007?
Provide a short and direct response. 0.87. What is the ratio of the Gross enrolment ratio (%) in Primary schools in 2006 to that in 2007?
Provide a succinct answer. 1.02. What is the ratio of the Gross enrolment ratio (%) of Secondary schools in 2006 to that in 2007?
Provide a succinct answer. 0.99. What is the ratio of the Gross enrolment ratio (%) in Tertiary schools in 2006 to that in 2007?
Your response must be concise. 0.9. What is the ratio of the Gross enrolment ratio (%) in Pre-primary schools in 2006 to that in 2008?
Your answer should be compact. 0.79. What is the ratio of the Gross enrolment ratio (%) in Primary schools in 2006 to that in 2008?
Offer a terse response. 1.03. What is the ratio of the Gross enrolment ratio (%) of Tertiary schools in 2006 to that in 2008?
Offer a terse response. 0.94. What is the ratio of the Gross enrolment ratio (%) in Pre-primary schools in 2007 to that in 2008?
Offer a very short reply. 0.91. What is the ratio of the Gross enrolment ratio (%) of Primary schools in 2007 to that in 2008?
Keep it short and to the point. 1.01. What is the ratio of the Gross enrolment ratio (%) of Tertiary schools in 2007 to that in 2008?
Ensure brevity in your answer.  1.04. What is the difference between the highest and the second highest Gross enrolment ratio (%) of Pre-primary schools?
Your response must be concise. 7.78. What is the difference between the highest and the second highest Gross enrolment ratio (%) in Primary schools?
Provide a succinct answer. 0.05. What is the difference between the highest and the second highest Gross enrolment ratio (%) in Secondary schools?
Offer a terse response. 0.03. What is the difference between the highest and the second highest Gross enrolment ratio (%) in Tertiary schools?
Provide a succinct answer. 0.04. What is the difference between the highest and the lowest Gross enrolment ratio (%) in Pre-primary schools?
Provide a short and direct response. 50.6. What is the difference between the highest and the lowest Gross enrolment ratio (%) in Primary schools?
Provide a short and direct response. 2.26. What is the difference between the highest and the lowest Gross enrolment ratio (%) of Secondary schools?
Provide a succinct answer. 0.98. What is the difference between the highest and the lowest Gross enrolment ratio (%) of Tertiary schools?
Keep it short and to the point. 0.23. 